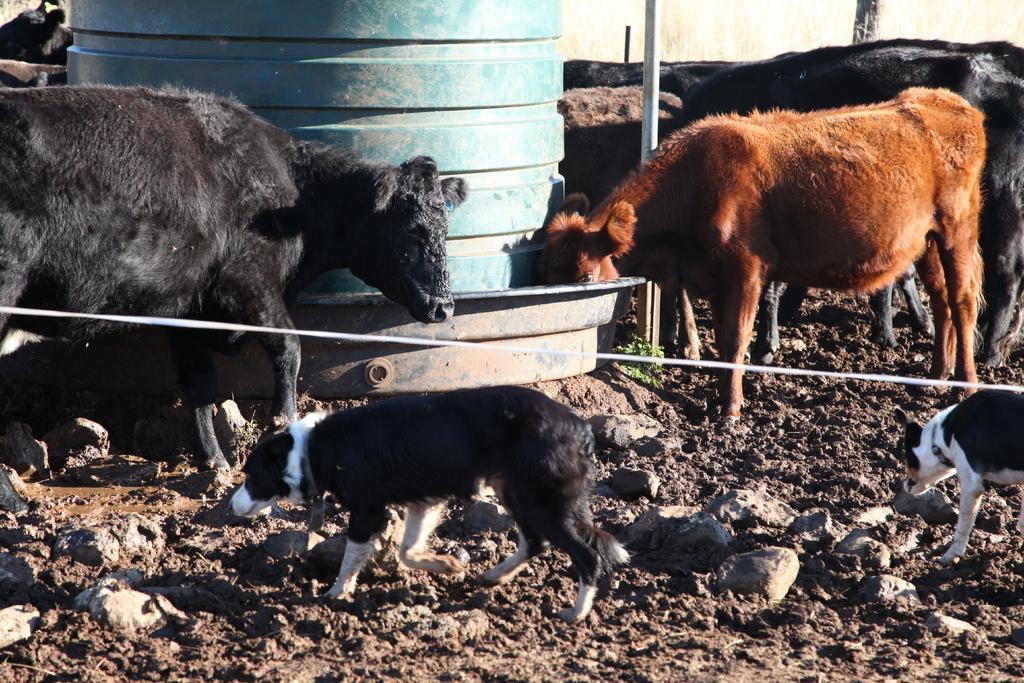In one or two sentences, can you explain what this image depicts? In this image, I can see the cows, dogs and a tank. At the bottom of the image, there are rocks. At the center of the image, It looks like a rope. 